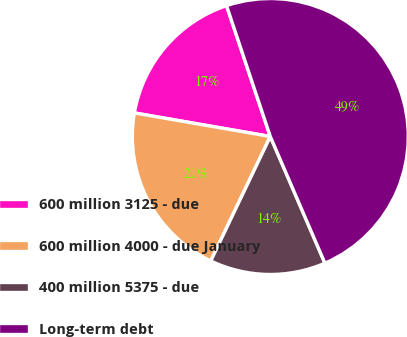Convert chart to OTSL. <chart><loc_0><loc_0><loc_500><loc_500><pie_chart><fcel>600 million 3125 - due<fcel>600 million 4000 - due January<fcel>400 million 5375 - due<fcel>Long-term debt<nl><fcel>17.13%<fcel>20.63%<fcel>13.58%<fcel>48.66%<nl></chart> 